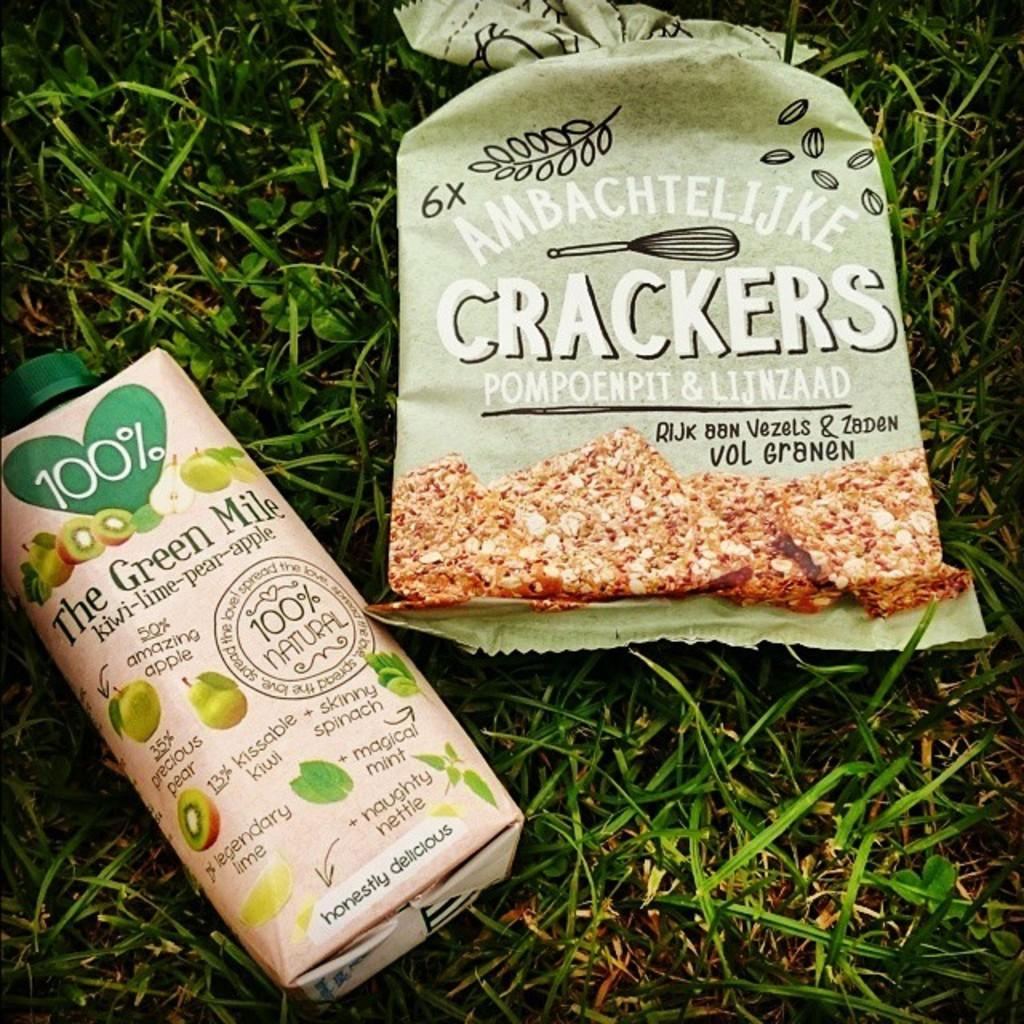<image>
Create a compact narrative representing the image presented. A package of Ambachtellijke Crackers next to a bottle of juice. 